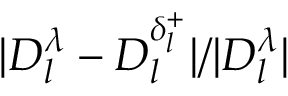Convert formula to latex. <formula><loc_0><loc_0><loc_500><loc_500>| D _ { l } ^ { \lambda } - D _ { l } ^ { \delta _ { l } ^ { + } } | / | D _ { l } ^ { \lambda } |</formula> 